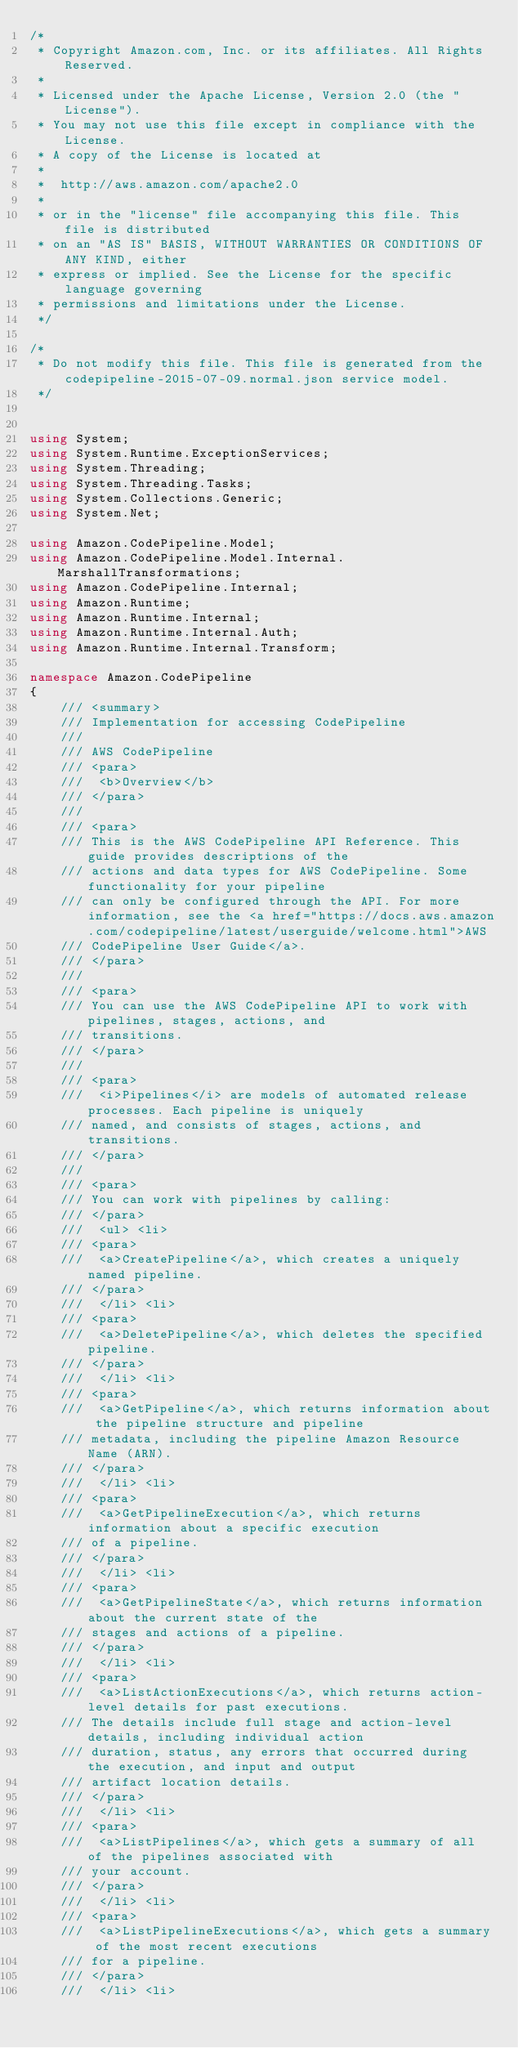<code> <loc_0><loc_0><loc_500><loc_500><_C#_>/*
 * Copyright Amazon.com, Inc. or its affiliates. All Rights Reserved.
 * 
 * Licensed under the Apache License, Version 2.0 (the "License").
 * You may not use this file except in compliance with the License.
 * A copy of the License is located at
 * 
 *  http://aws.amazon.com/apache2.0
 * 
 * or in the "license" file accompanying this file. This file is distributed
 * on an "AS IS" BASIS, WITHOUT WARRANTIES OR CONDITIONS OF ANY KIND, either
 * express or implied. See the License for the specific language governing
 * permissions and limitations under the License.
 */

/*
 * Do not modify this file. This file is generated from the codepipeline-2015-07-09.normal.json service model.
 */


using System;
using System.Runtime.ExceptionServices;
using System.Threading;
using System.Threading.Tasks;
using System.Collections.Generic;
using System.Net;

using Amazon.CodePipeline.Model;
using Amazon.CodePipeline.Model.Internal.MarshallTransformations;
using Amazon.CodePipeline.Internal;
using Amazon.Runtime;
using Amazon.Runtime.Internal;
using Amazon.Runtime.Internal.Auth;
using Amazon.Runtime.Internal.Transform;

namespace Amazon.CodePipeline
{
    /// <summary>
    /// Implementation for accessing CodePipeline
    ///
    /// AWS CodePipeline 
    /// <para>
    ///  <b>Overview</b> 
    /// </para>
    ///  
    /// <para>
    /// This is the AWS CodePipeline API Reference. This guide provides descriptions of the
    /// actions and data types for AWS CodePipeline. Some functionality for your pipeline
    /// can only be configured through the API. For more information, see the <a href="https://docs.aws.amazon.com/codepipeline/latest/userguide/welcome.html">AWS
    /// CodePipeline User Guide</a>.
    /// </para>
    ///  
    /// <para>
    /// You can use the AWS CodePipeline API to work with pipelines, stages, actions, and
    /// transitions.
    /// </para>
    ///  
    /// <para>
    ///  <i>Pipelines</i> are models of automated release processes. Each pipeline is uniquely
    /// named, and consists of stages, actions, and transitions. 
    /// </para>
    ///  
    /// <para>
    /// You can work with pipelines by calling:
    /// </para>
    ///  <ul> <li> 
    /// <para>
    ///  <a>CreatePipeline</a>, which creates a uniquely named pipeline.
    /// </para>
    ///  </li> <li> 
    /// <para>
    ///  <a>DeletePipeline</a>, which deletes the specified pipeline.
    /// </para>
    ///  </li> <li> 
    /// <para>
    ///  <a>GetPipeline</a>, which returns information about the pipeline structure and pipeline
    /// metadata, including the pipeline Amazon Resource Name (ARN).
    /// </para>
    ///  </li> <li> 
    /// <para>
    ///  <a>GetPipelineExecution</a>, which returns information about a specific execution
    /// of a pipeline.
    /// </para>
    ///  </li> <li> 
    /// <para>
    ///  <a>GetPipelineState</a>, which returns information about the current state of the
    /// stages and actions of a pipeline.
    /// </para>
    ///  </li> <li> 
    /// <para>
    ///  <a>ListActionExecutions</a>, which returns action-level details for past executions.
    /// The details include full stage and action-level details, including individual action
    /// duration, status, any errors that occurred during the execution, and input and output
    /// artifact location details.
    /// </para>
    ///  </li> <li> 
    /// <para>
    ///  <a>ListPipelines</a>, which gets a summary of all of the pipelines associated with
    /// your account.
    /// </para>
    ///  </li> <li> 
    /// <para>
    ///  <a>ListPipelineExecutions</a>, which gets a summary of the most recent executions
    /// for a pipeline.
    /// </para>
    ///  </li> <li> </code> 